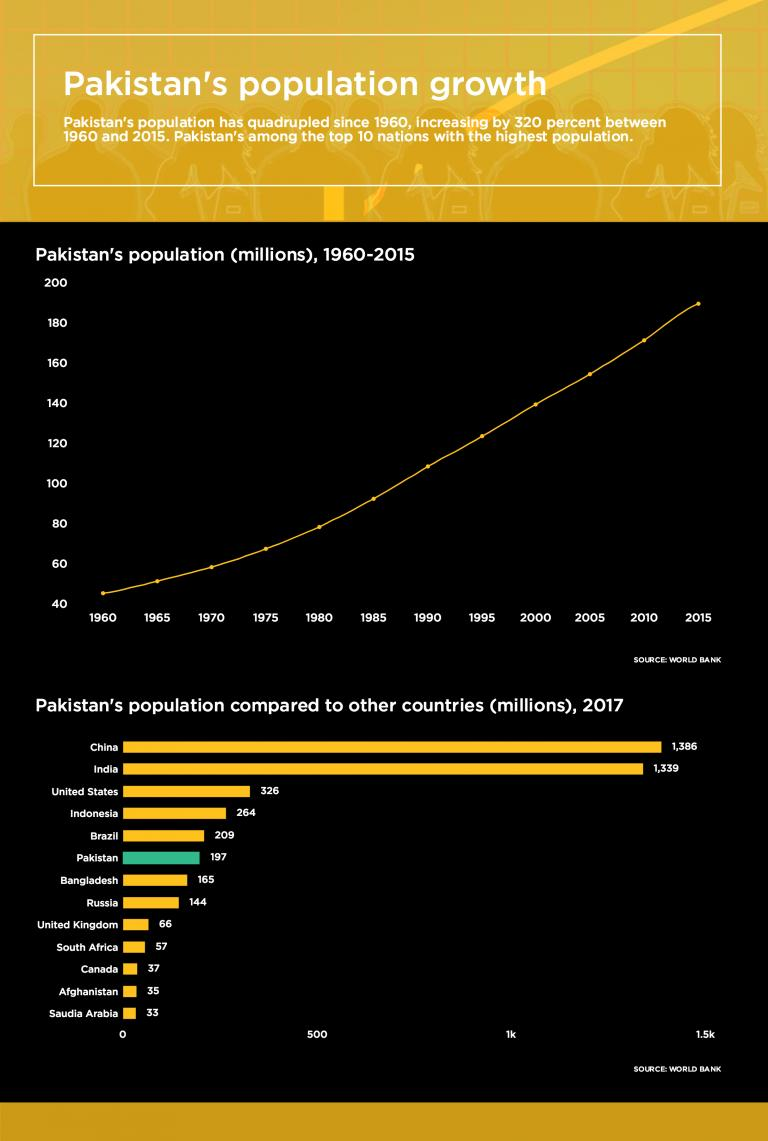Highlight a few significant elements in this photo. The number of countries with a population of less than 500 million is 11. There are 3 countries with a population of less than 50 million. It is estimated that Canada, Afghanistan, and Saudi Arabia are countries with less than 50 million inhabitants. 